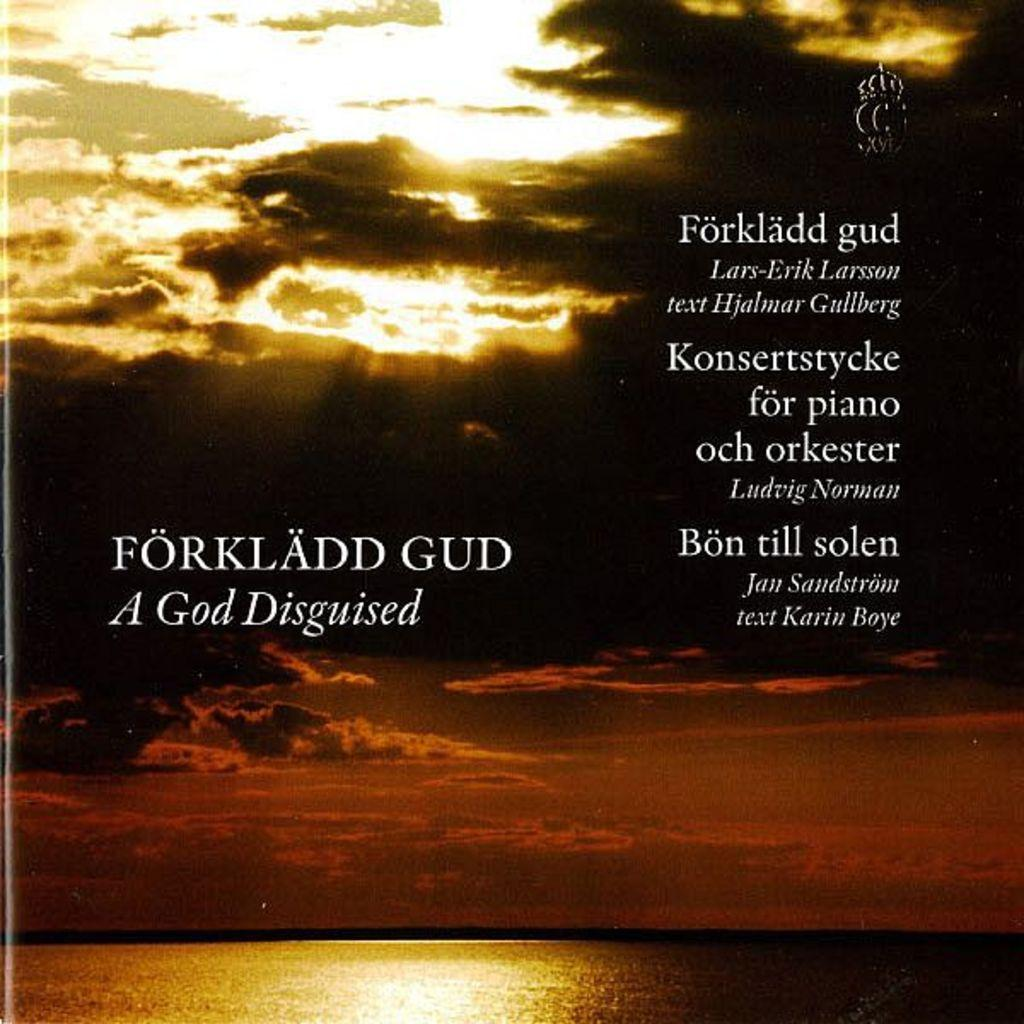<image>
Render a clear and concise summary of the photo. The ocean with the caption A God Disguised. 